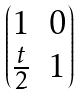Convert formula to latex. <formula><loc_0><loc_0><loc_500><loc_500>\begin{pmatrix} 1 & 0 \\ \frac { t } { 2 } & 1 \end{pmatrix}</formula> 